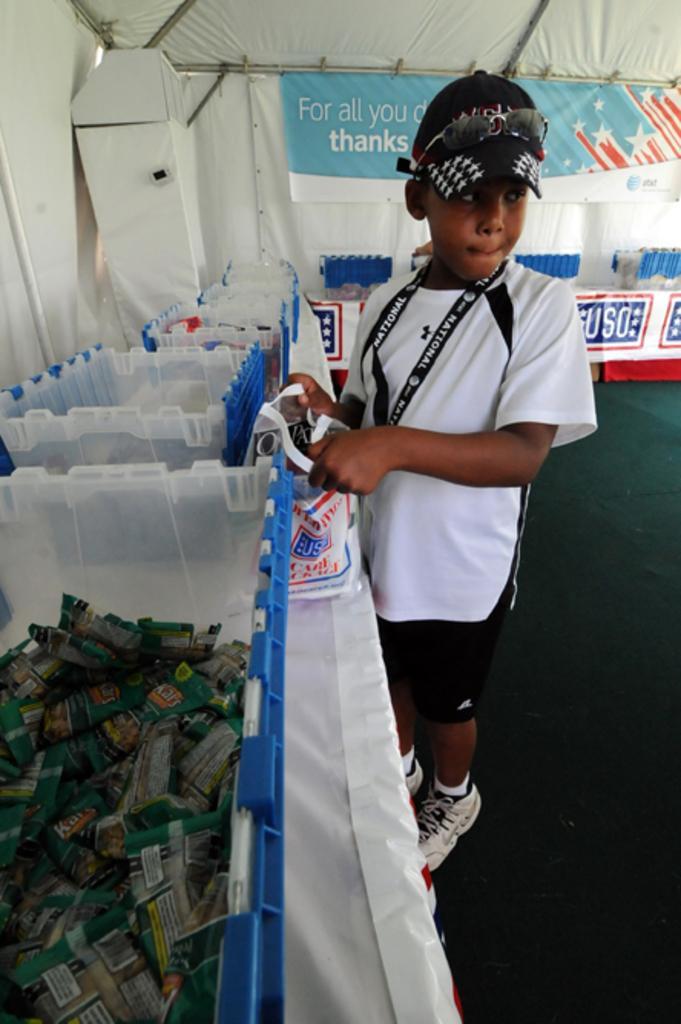Describe this image in one or two sentences. On the left side of the picture we can see a table with a white sheet cover. On the table we can see containers. In this container there are some packets. Near to the table there is one boy standing and holding a carry bag in his hands. This is a green colour carpet. On the background we can see a white colour tent with hoarding. 